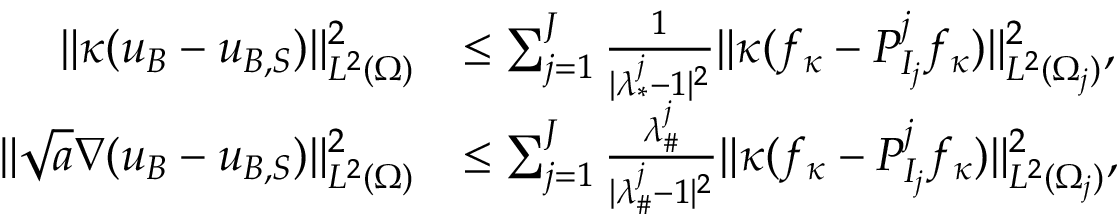<formula> <loc_0><loc_0><loc_500><loc_500>\begin{array} { r l } { \| \kappa ( u _ { B } - u _ { B , S } ) \| _ { L ^ { 2 } ( \Omega ) } ^ { 2 } } & { \leq \sum _ { j = 1 } ^ { J } \frac { 1 } { | { \lambda _ { * } ^ { j } } - 1 | ^ { 2 } } \| \kappa ( f _ { \kappa } - P _ { I _ { j } } ^ { j } f _ { \kappa } ) \| _ { L ^ { 2 } ( \Omega _ { j } ) } ^ { 2 } , } \\ { \| \sqrt { a } \nabla ( u _ { B } - u _ { B , S } ) \| _ { L ^ { 2 } ( \Omega ) } ^ { 2 } } & { \leq \sum _ { j = 1 } ^ { J } \frac { \lambda _ { \# } ^ { j } } { | \lambda _ { \# } ^ { j } - 1 | ^ { 2 } } \| \kappa ( f _ { \kappa } - P _ { I _ { j } } ^ { j } f _ { \kappa } ) \| _ { L ^ { 2 } ( \Omega _ { j } ) } ^ { 2 } , } \end{array}</formula> 